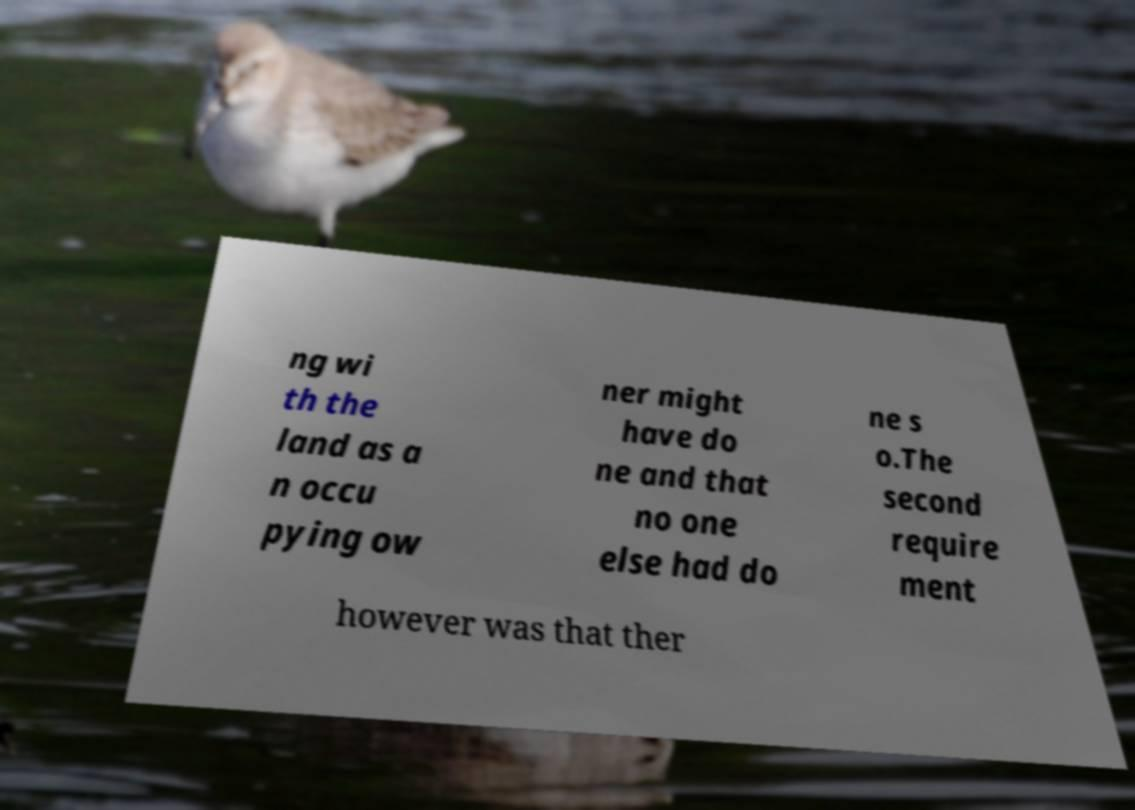There's text embedded in this image that I need extracted. Can you transcribe it verbatim? ng wi th the land as a n occu pying ow ner might have do ne and that no one else had do ne s o.The second require ment however was that ther 